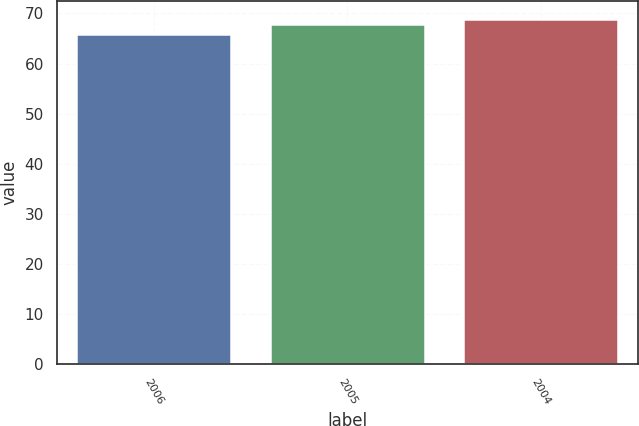Convert chart to OTSL. <chart><loc_0><loc_0><loc_500><loc_500><bar_chart><fcel>2006<fcel>2005<fcel>2004<nl><fcel>66<fcel>68<fcel>69<nl></chart> 